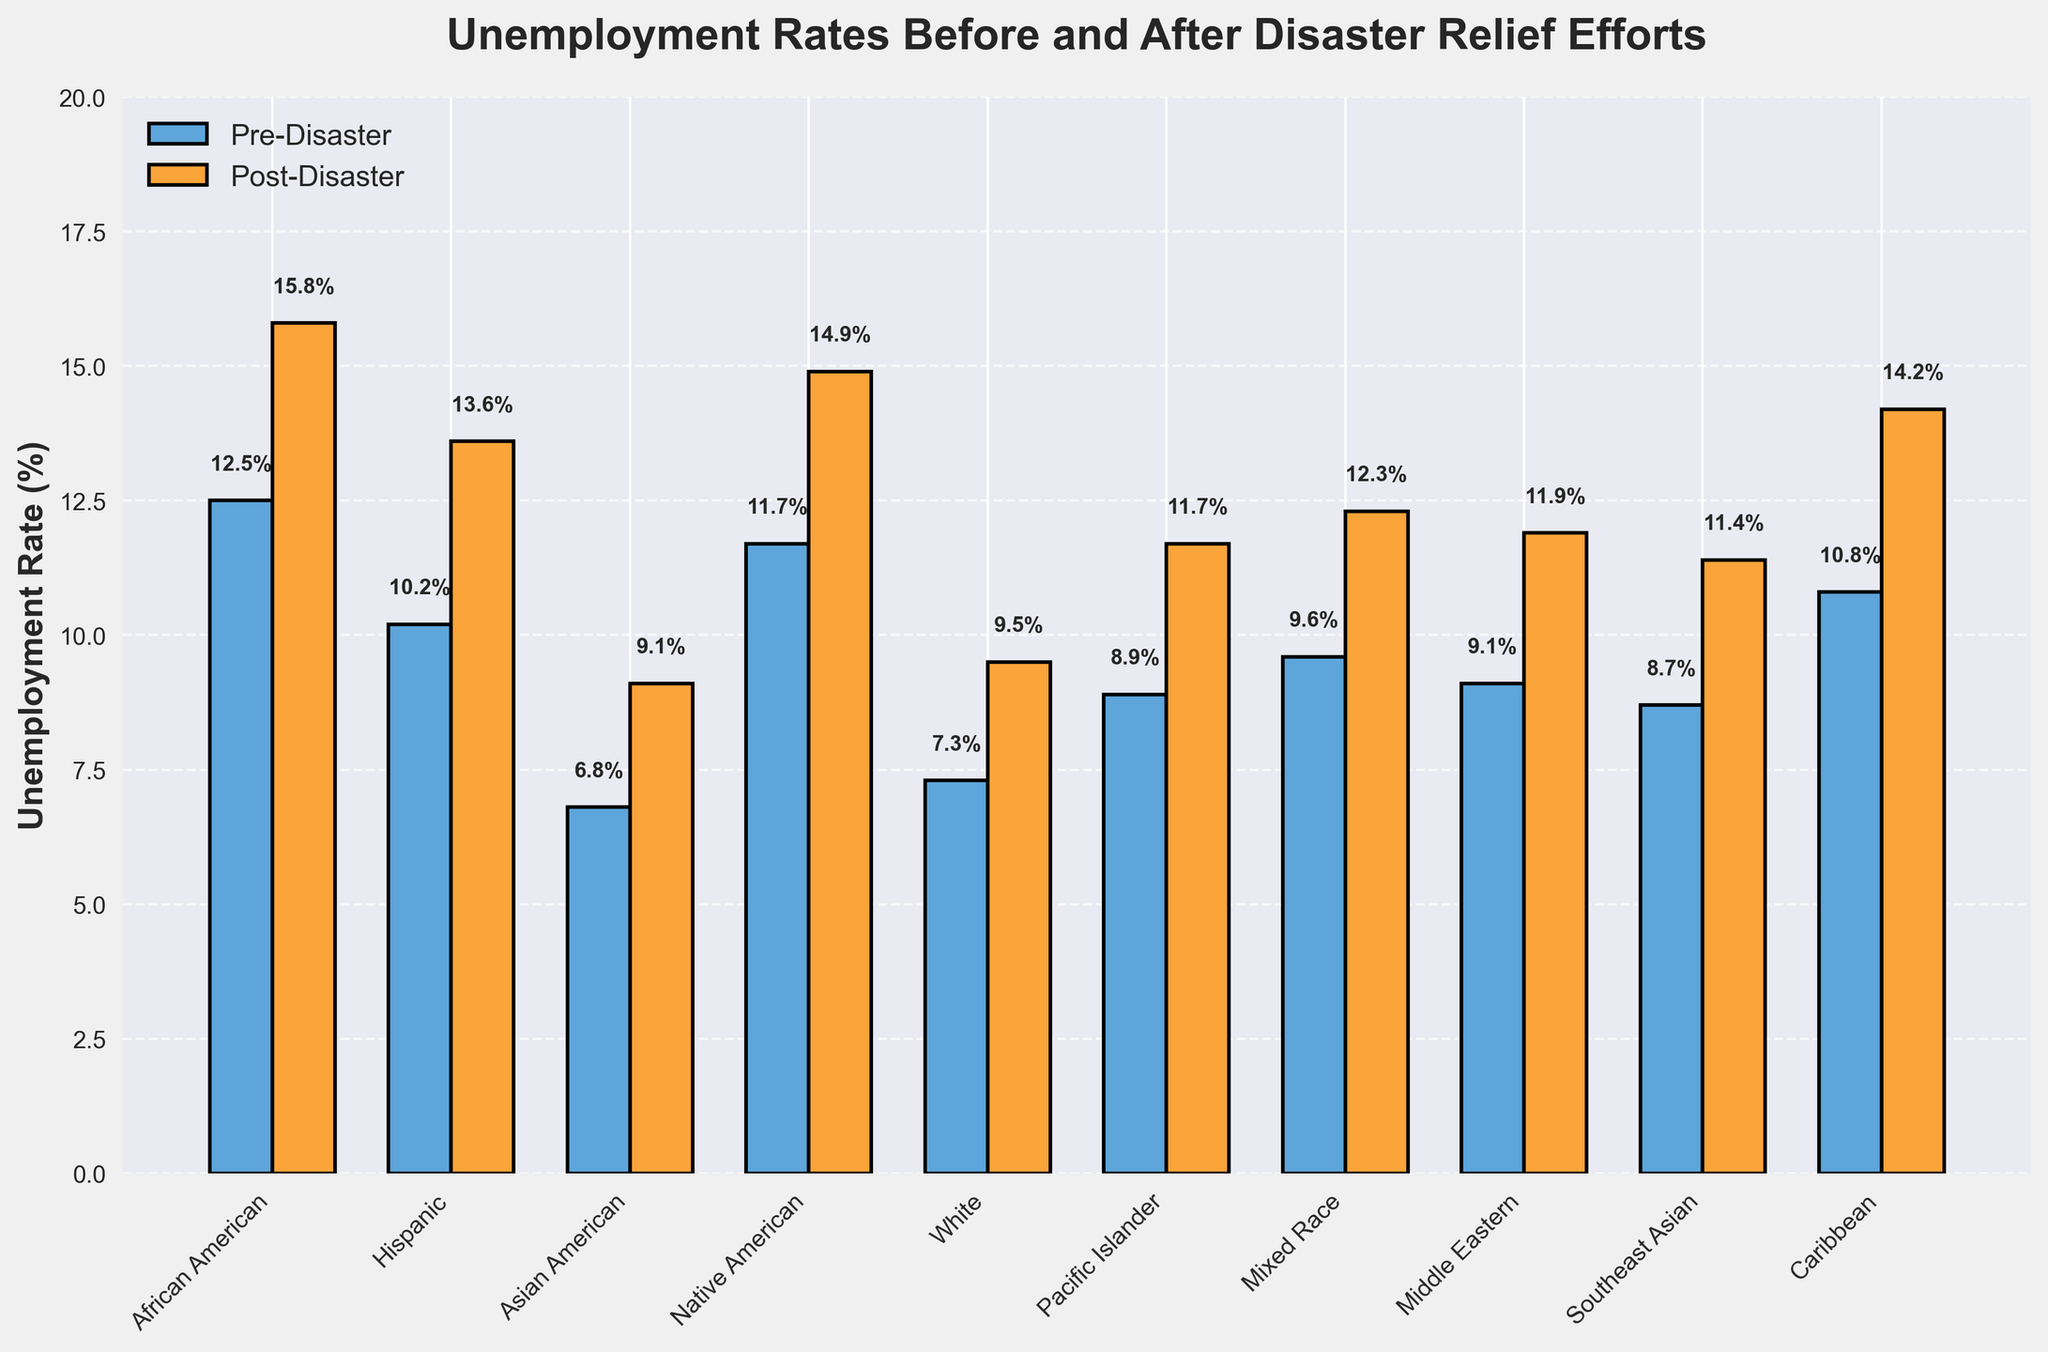What is the post-disaster unemployment rate for the Hispanic group? The figure shows different colored bars for pre-disaster and post-disaster. For the Hispanic group, locate the corresponding post-disaster bar (orange) and read the value.
Answer: 13.6% Which ethnic group experienced the highest post-disaster unemployment rate? Compare the heights of all orange bars marking the post-disaster unemployment rate to identify the tallest one.
Answer: African American By how much did the unemployment rate increase for the Native American group post-disaster? Subtract the pre-disaster unemployment rate of Native American group (11.7%) from the post-disaster rate (14.9%).
Answer: 3.2% Which group had the least increase in unemployment rate after the disaster? For each group, subtract the pre-disaster rate from the post-disaster rate and identify the smallest difference.
Answer: Asian American How does the pre-disaster unemployment rate of the African American group compare with the post-disaster unemployment rate of the White group? Locate the pre-disaster bar for African American (12.5%) and compare it to the post-disaster bar for White (9.5%).
Answer: Greater What is the average post-disaster unemployment rate across all ethnic groups? Sum up all the post-disaster unemployment rates and divide by the number of groups (10). Calculation: (15.8 + 13.6 + 9.1 + 14.9 + 9.5 + 11.7 + 12.3 + 11.9 + 11.4 + 14.2) / 10
Answer: 12.44% Which group had a pre-disaster unemployment rate closest to 10%? Identify the pre-disaster bar (blue) close to the 10% mark, focusing on numeric values.
Answer: Hispanic By how much did the unemployment rate increase for the Caribbean group post-disaster? Subtract the pre-disaster rate of the Caribbean group (10.8%) from the post-disaster rate (14.2%).
Answer: 3.4% Identify the groups that have a post-disaster unemployment rate above 14%. Observe all orange bars and list groups with heights above 14%.
Answer: African American, Native American, Caribbean Which group showed an increase in unemployment rate greater than 3% but less than 4% after the disaster? For each group, calculate the difference between the pre- and post-disaster rates to determine which falls within the specified range.
Answer: Native American, Caribbean 